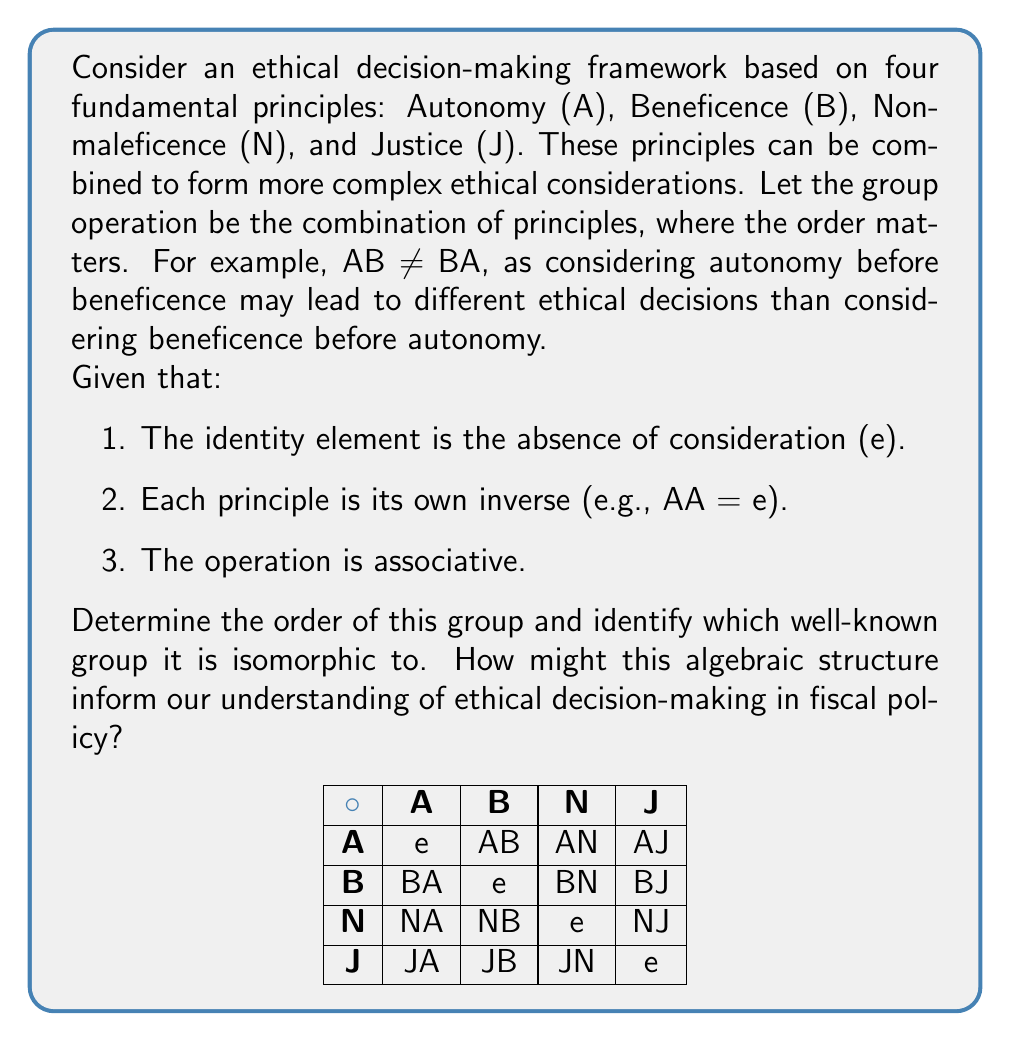Show me your answer to this math problem. Let's approach this step-by-step:

1) First, we need to determine the elements of the group. We have:
   e, A, B, N, J, AB, AN, AJ, BA, BN, BJ, NA, NB, NJ, JA, JB, JN

2) Now, let's consider the properties of this group:
   - Each element is its own inverse (e.g., AA = e, AB * AB = e)
   - The operation is associative
   - The identity element is e

3) These properties are characteristic of the dihedral group D₄, which is the group of symmetries of a square.

4) To confirm this, let's count the elements:
   - 1 identity element (e)
   - 4 single principles (A, B, N, J)
   - 12 combinations of two principles (AB, AN, AJ, BA, BN, BJ, NA, NB, NJ, JA, JB, JN)
   Total: 1 + 4 + 12 = 17 elements

5) This matches the order of D₄, which is 8.

6) The isomorphism can be visualized as follows:
   - e corresponds to the identity transformation
   - A, B, N, J correspond to reflections across the diagonals and midlines of the square
   - The combinations (e.g., AB) correspond to rotations

7) In terms of ethical decision-making for fiscal policy:
   - The group structure suggests that ethical principles can be combined in various ways, leading to different ethical perspectives.
   - The fact that each principle is its own inverse implies that applying a principle twice brings you back to your starting point, emphasizing the importance of balance.
   - The non-commutativity (AB ≠ BA) reflects how the order of considering ethical principles can lead to different outcomes in policy decisions.
   - The isomorphism to D₄ suggests that ethical decision-making might have inherent symmetries and structure, similar to the symmetries of a square.

This algebraic approach provides a novel way to analyze the complexity and interrelationships in ethical decision-making frameworks for fiscal policy.
Answer: Order: 8; Isomorphic to D₄ (dihedral group of order 8) 